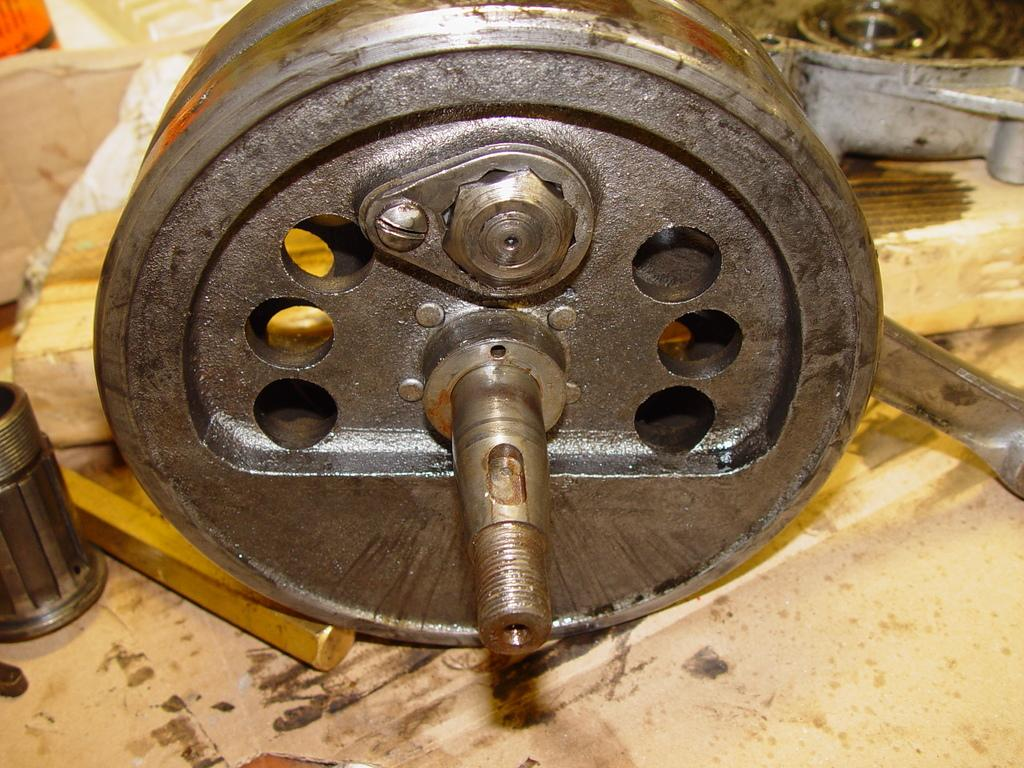What type of objects can be seen in the image? There are metal objects in the image. What other material is present in the image? There is a wooden plank in the image. Where are the metal objects and wooden plank located? The metal objects and wooden plank are on the ground. What type of bird can be seen perched on the wooden plank in the image? There is no bird present in the image; it only features metal objects and a wooden plank on the ground. 